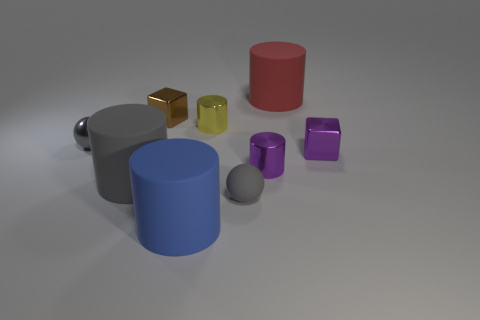There is a block that is on the right side of the small metal block behind the tiny yellow metal object; what is it made of?
Provide a short and direct response. Metal. What number of objects are cylinders or rubber cylinders behind the blue matte cylinder?
Offer a terse response. 5. There is a sphere that is made of the same material as the large red object; what size is it?
Offer a very short reply. Small. What number of purple objects are either metal blocks or balls?
Give a very brief answer. 1. There is a big matte object that is the same color as the tiny rubber object; what shape is it?
Offer a terse response. Cylinder. There is a tiny purple shiny object that is behind the tiny purple cylinder; is its shape the same as the small brown metallic object that is on the left side of the tiny purple cube?
Provide a succinct answer. Yes. What number of big red objects are there?
Your answer should be very brief. 1. What is the shape of the large blue thing that is the same material as the big red cylinder?
Offer a very short reply. Cylinder. There is a rubber sphere; is it the same color as the tiny cylinder that is in front of the small purple block?
Provide a short and direct response. No. Are there fewer tiny purple metal cubes that are on the left side of the small gray rubber thing than large rubber balls?
Give a very brief answer. No. 